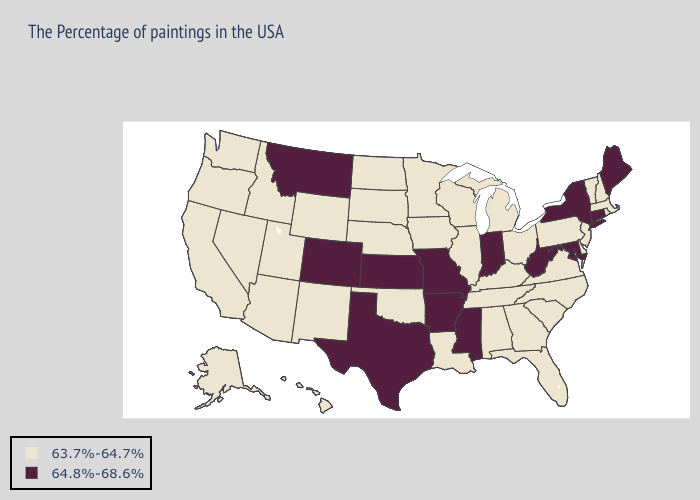Among the states that border Michigan , does Indiana have the lowest value?
Write a very short answer. No. Does Delaware have a higher value than Missouri?
Quick response, please. No. Which states hav the highest value in the Northeast?
Keep it brief. Maine, Connecticut, New York. What is the highest value in the Northeast ?
Write a very short answer. 64.8%-68.6%. Which states hav the highest value in the South?
Quick response, please. Maryland, West Virginia, Mississippi, Arkansas, Texas. What is the highest value in the West ?
Keep it brief. 64.8%-68.6%. What is the lowest value in states that border New Mexico?
Give a very brief answer. 63.7%-64.7%. What is the value of Nebraska?
Write a very short answer. 63.7%-64.7%. What is the lowest value in the MidWest?
Quick response, please. 63.7%-64.7%. What is the value of Hawaii?
Quick response, please. 63.7%-64.7%. Does Delaware have a lower value than Montana?
Quick response, please. Yes. Among the states that border Iowa , which have the lowest value?
Write a very short answer. Wisconsin, Illinois, Minnesota, Nebraska, South Dakota. What is the value of Maine?
Concise answer only. 64.8%-68.6%. What is the lowest value in the USA?
Answer briefly. 63.7%-64.7%. Name the states that have a value in the range 63.7%-64.7%?
Concise answer only. Massachusetts, Rhode Island, New Hampshire, Vermont, New Jersey, Delaware, Pennsylvania, Virginia, North Carolina, South Carolina, Ohio, Florida, Georgia, Michigan, Kentucky, Alabama, Tennessee, Wisconsin, Illinois, Louisiana, Minnesota, Iowa, Nebraska, Oklahoma, South Dakota, North Dakota, Wyoming, New Mexico, Utah, Arizona, Idaho, Nevada, California, Washington, Oregon, Alaska, Hawaii. 